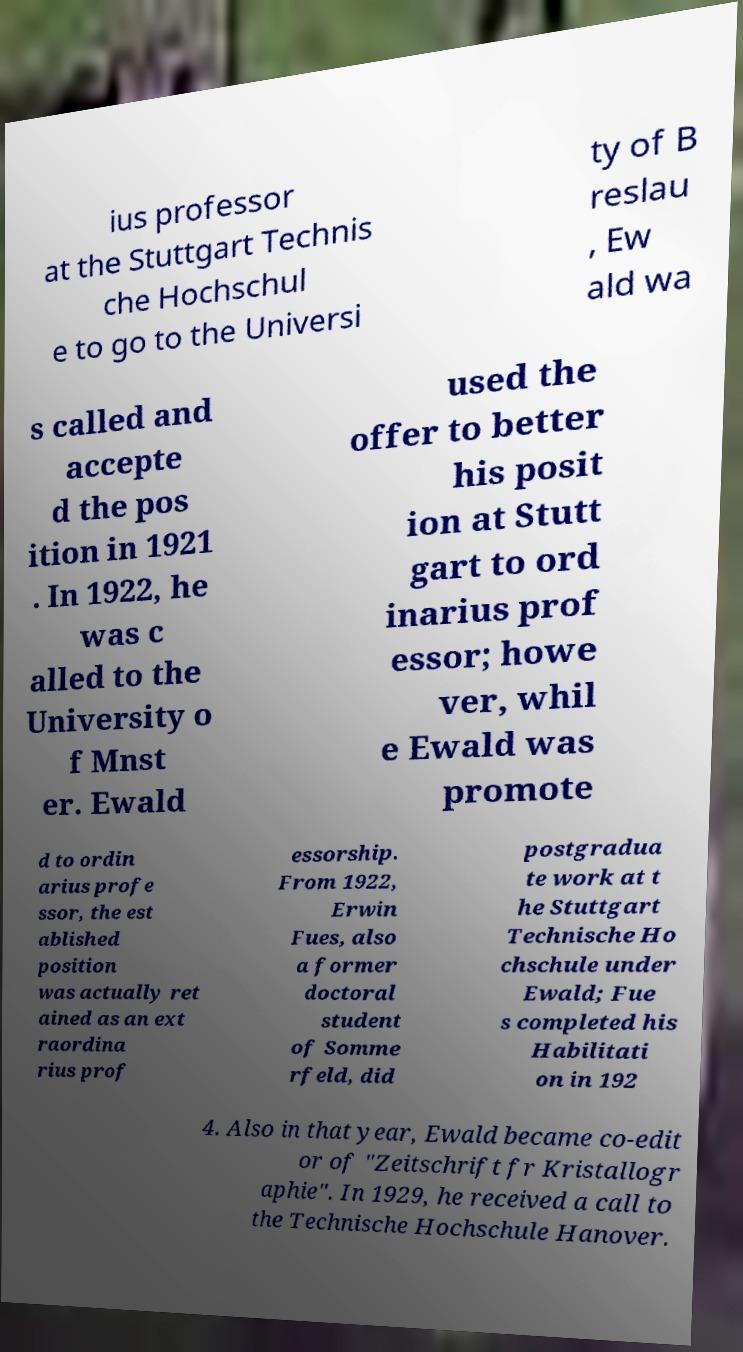Could you assist in decoding the text presented in this image and type it out clearly? ius professor at the Stuttgart Technis che Hochschul e to go to the Universi ty of B reslau , Ew ald wa s called and accepte d the pos ition in 1921 . In 1922, he was c alled to the University o f Mnst er. Ewald used the offer to better his posit ion at Stutt gart to ord inarius prof essor; howe ver, whil e Ewald was promote d to ordin arius profe ssor, the est ablished position was actually ret ained as an ext raordina rius prof essorship. From 1922, Erwin Fues, also a former doctoral student of Somme rfeld, did postgradua te work at t he Stuttgart Technische Ho chschule under Ewald; Fue s completed his Habilitati on in 192 4. Also in that year, Ewald became co-edit or of "Zeitschrift fr Kristallogr aphie". In 1929, he received a call to the Technische Hochschule Hanover. 